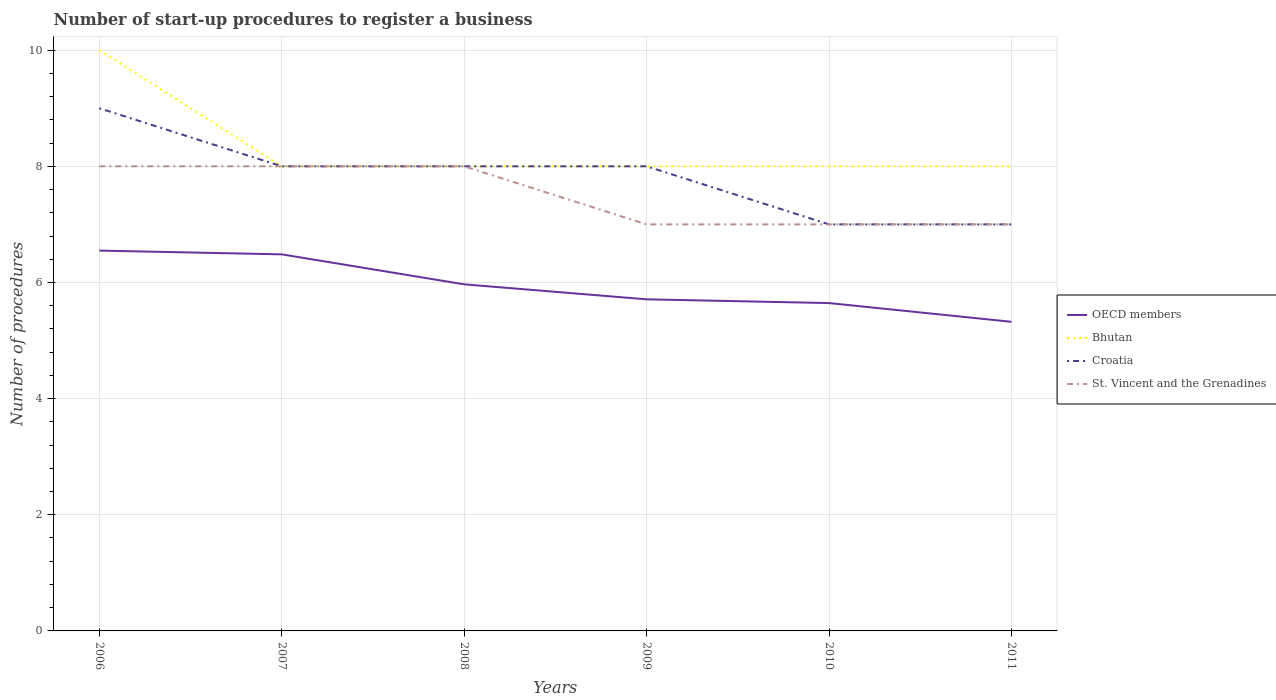Across all years, what is the maximum number of procedures required to register a business in Croatia?
Provide a succinct answer. 7. What is the difference between the highest and the second highest number of procedures required to register a business in Croatia?
Offer a very short reply. 2. How many lines are there?
Make the answer very short. 4. How many years are there in the graph?
Provide a short and direct response. 6. Are the values on the major ticks of Y-axis written in scientific E-notation?
Your answer should be compact. No. Does the graph contain any zero values?
Provide a succinct answer. No. How many legend labels are there?
Keep it short and to the point. 4. What is the title of the graph?
Provide a short and direct response. Number of start-up procedures to register a business. What is the label or title of the Y-axis?
Offer a terse response. Number of procedures. What is the Number of procedures in OECD members in 2006?
Give a very brief answer. 6.55. What is the Number of procedures of OECD members in 2007?
Your response must be concise. 6.48. What is the Number of procedures in OECD members in 2008?
Provide a short and direct response. 5.97. What is the Number of procedures of Croatia in 2008?
Your answer should be very brief. 8. What is the Number of procedures in OECD members in 2009?
Offer a very short reply. 5.71. What is the Number of procedures in St. Vincent and the Grenadines in 2009?
Keep it short and to the point. 7. What is the Number of procedures of OECD members in 2010?
Provide a succinct answer. 5.65. What is the Number of procedures in Bhutan in 2010?
Keep it short and to the point. 8. What is the Number of procedures of Croatia in 2010?
Your answer should be very brief. 7. What is the Number of procedures of OECD members in 2011?
Your answer should be very brief. 5.32. What is the Number of procedures of Croatia in 2011?
Give a very brief answer. 7. What is the Number of procedures of St. Vincent and the Grenadines in 2011?
Keep it short and to the point. 7. Across all years, what is the maximum Number of procedures of OECD members?
Your answer should be compact. 6.55. Across all years, what is the maximum Number of procedures in Bhutan?
Keep it short and to the point. 10. Across all years, what is the maximum Number of procedures of St. Vincent and the Grenadines?
Keep it short and to the point. 8. Across all years, what is the minimum Number of procedures of OECD members?
Your answer should be compact. 5.32. Across all years, what is the minimum Number of procedures in Croatia?
Provide a short and direct response. 7. What is the total Number of procedures in OECD members in the graph?
Your response must be concise. 35.68. What is the total Number of procedures of Bhutan in the graph?
Give a very brief answer. 50. What is the difference between the Number of procedures in OECD members in 2006 and that in 2007?
Make the answer very short. 0.06. What is the difference between the Number of procedures in Bhutan in 2006 and that in 2007?
Your answer should be compact. 2. What is the difference between the Number of procedures in Croatia in 2006 and that in 2007?
Your response must be concise. 1. What is the difference between the Number of procedures in St. Vincent and the Grenadines in 2006 and that in 2007?
Offer a very short reply. 0. What is the difference between the Number of procedures in OECD members in 2006 and that in 2008?
Your answer should be very brief. 0.58. What is the difference between the Number of procedures of St. Vincent and the Grenadines in 2006 and that in 2008?
Provide a short and direct response. 0. What is the difference between the Number of procedures in OECD members in 2006 and that in 2009?
Make the answer very short. 0.84. What is the difference between the Number of procedures of St. Vincent and the Grenadines in 2006 and that in 2009?
Offer a very short reply. 1. What is the difference between the Number of procedures in OECD members in 2006 and that in 2010?
Provide a short and direct response. 0.9. What is the difference between the Number of procedures in Bhutan in 2006 and that in 2010?
Make the answer very short. 2. What is the difference between the Number of procedures in Croatia in 2006 and that in 2010?
Your answer should be compact. 2. What is the difference between the Number of procedures of St. Vincent and the Grenadines in 2006 and that in 2010?
Provide a succinct answer. 1. What is the difference between the Number of procedures of OECD members in 2006 and that in 2011?
Make the answer very short. 1.23. What is the difference between the Number of procedures in Bhutan in 2006 and that in 2011?
Ensure brevity in your answer.  2. What is the difference between the Number of procedures in St. Vincent and the Grenadines in 2006 and that in 2011?
Provide a short and direct response. 1. What is the difference between the Number of procedures in OECD members in 2007 and that in 2008?
Ensure brevity in your answer.  0.52. What is the difference between the Number of procedures of Bhutan in 2007 and that in 2008?
Keep it short and to the point. 0. What is the difference between the Number of procedures of Croatia in 2007 and that in 2008?
Your answer should be very brief. 0. What is the difference between the Number of procedures in OECD members in 2007 and that in 2009?
Offer a terse response. 0.77. What is the difference between the Number of procedures of Bhutan in 2007 and that in 2009?
Provide a short and direct response. 0. What is the difference between the Number of procedures of OECD members in 2007 and that in 2010?
Make the answer very short. 0.84. What is the difference between the Number of procedures of Bhutan in 2007 and that in 2010?
Make the answer very short. 0. What is the difference between the Number of procedures in St. Vincent and the Grenadines in 2007 and that in 2010?
Ensure brevity in your answer.  1. What is the difference between the Number of procedures in OECD members in 2007 and that in 2011?
Keep it short and to the point. 1.16. What is the difference between the Number of procedures of Bhutan in 2007 and that in 2011?
Ensure brevity in your answer.  0. What is the difference between the Number of procedures of Croatia in 2007 and that in 2011?
Keep it short and to the point. 1. What is the difference between the Number of procedures in St. Vincent and the Grenadines in 2007 and that in 2011?
Your response must be concise. 1. What is the difference between the Number of procedures of OECD members in 2008 and that in 2009?
Provide a succinct answer. 0.26. What is the difference between the Number of procedures in Bhutan in 2008 and that in 2009?
Your response must be concise. 0. What is the difference between the Number of procedures of OECD members in 2008 and that in 2010?
Offer a very short reply. 0.32. What is the difference between the Number of procedures of Bhutan in 2008 and that in 2010?
Keep it short and to the point. 0. What is the difference between the Number of procedures in Croatia in 2008 and that in 2010?
Keep it short and to the point. 1. What is the difference between the Number of procedures in OECD members in 2008 and that in 2011?
Offer a terse response. 0.65. What is the difference between the Number of procedures of St. Vincent and the Grenadines in 2008 and that in 2011?
Your response must be concise. 1. What is the difference between the Number of procedures in OECD members in 2009 and that in 2010?
Make the answer very short. 0.06. What is the difference between the Number of procedures of Croatia in 2009 and that in 2010?
Your answer should be compact. 1. What is the difference between the Number of procedures in OECD members in 2009 and that in 2011?
Offer a terse response. 0.39. What is the difference between the Number of procedures in Croatia in 2009 and that in 2011?
Your answer should be very brief. 1. What is the difference between the Number of procedures of St. Vincent and the Grenadines in 2009 and that in 2011?
Provide a succinct answer. 0. What is the difference between the Number of procedures of OECD members in 2010 and that in 2011?
Keep it short and to the point. 0.32. What is the difference between the Number of procedures of Bhutan in 2010 and that in 2011?
Provide a short and direct response. 0. What is the difference between the Number of procedures in OECD members in 2006 and the Number of procedures in Bhutan in 2007?
Provide a succinct answer. -1.45. What is the difference between the Number of procedures of OECD members in 2006 and the Number of procedures of Croatia in 2007?
Provide a short and direct response. -1.45. What is the difference between the Number of procedures in OECD members in 2006 and the Number of procedures in St. Vincent and the Grenadines in 2007?
Your answer should be very brief. -1.45. What is the difference between the Number of procedures in Bhutan in 2006 and the Number of procedures in Croatia in 2007?
Keep it short and to the point. 2. What is the difference between the Number of procedures in Bhutan in 2006 and the Number of procedures in St. Vincent and the Grenadines in 2007?
Make the answer very short. 2. What is the difference between the Number of procedures of Croatia in 2006 and the Number of procedures of St. Vincent and the Grenadines in 2007?
Offer a very short reply. 1. What is the difference between the Number of procedures of OECD members in 2006 and the Number of procedures of Bhutan in 2008?
Provide a short and direct response. -1.45. What is the difference between the Number of procedures in OECD members in 2006 and the Number of procedures in Croatia in 2008?
Your response must be concise. -1.45. What is the difference between the Number of procedures of OECD members in 2006 and the Number of procedures of St. Vincent and the Grenadines in 2008?
Make the answer very short. -1.45. What is the difference between the Number of procedures in Bhutan in 2006 and the Number of procedures in St. Vincent and the Grenadines in 2008?
Your answer should be very brief. 2. What is the difference between the Number of procedures of OECD members in 2006 and the Number of procedures of Bhutan in 2009?
Provide a short and direct response. -1.45. What is the difference between the Number of procedures in OECD members in 2006 and the Number of procedures in Croatia in 2009?
Offer a terse response. -1.45. What is the difference between the Number of procedures of OECD members in 2006 and the Number of procedures of St. Vincent and the Grenadines in 2009?
Provide a succinct answer. -0.45. What is the difference between the Number of procedures in Bhutan in 2006 and the Number of procedures in Croatia in 2009?
Offer a terse response. 2. What is the difference between the Number of procedures in OECD members in 2006 and the Number of procedures in Bhutan in 2010?
Provide a succinct answer. -1.45. What is the difference between the Number of procedures in OECD members in 2006 and the Number of procedures in Croatia in 2010?
Offer a terse response. -0.45. What is the difference between the Number of procedures of OECD members in 2006 and the Number of procedures of St. Vincent and the Grenadines in 2010?
Your answer should be very brief. -0.45. What is the difference between the Number of procedures in Bhutan in 2006 and the Number of procedures in Croatia in 2010?
Provide a short and direct response. 3. What is the difference between the Number of procedures of Bhutan in 2006 and the Number of procedures of St. Vincent and the Grenadines in 2010?
Your response must be concise. 3. What is the difference between the Number of procedures in OECD members in 2006 and the Number of procedures in Bhutan in 2011?
Provide a succinct answer. -1.45. What is the difference between the Number of procedures of OECD members in 2006 and the Number of procedures of Croatia in 2011?
Your answer should be very brief. -0.45. What is the difference between the Number of procedures in OECD members in 2006 and the Number of procedures in St. Vincent and the Grenadines in 2011?
Provide a succinct answer. -0.45. What is the difference between the Number of procedures in Croatia in 2006 and the Number of procedures in St. Vincent and the Grenadines in 2011?
Your answer should be compact. 2. What is the difference between the Number of procedures in OECD members in 2007 and the Number of procedures in Bhutan in 2008?
Offer a very short reply. -1.52. What is the difference between the Number of procedures of OECD members in 2007 and the Number of procedures of Croatia in 2008?
Offer a terse response. -1.52. What is the difference between the Number of procedures in OECD members in 2007 and the Number of procedures in St. Vincent and the Grenadines in 2008?
Ensure brevity in your answer.  -1.52. What is the difference between the Number of procedures in Bhutan in 2007 and the Number of procedures in Croatia in 2008?
Keep it short and to the point. 0. What is the difference between the Number of procedures of OECD members in 2007 and the Number of procedures of Bhutan in 2009?
Offer a terse response. -1.52. What is the difference between the Number of procedures in OECD members in 2007 and the Number of procedures in Croatia in 2009?
Provide a succinct answer. -1.52. What is the difference between the Number of procedures of OECD members in 2007 and the Number of procedures of St. Vincent and the Grenadines in 2009?
Your response must be concise. -0.52. What is the difference between the Number of procedures of Bhutan in 2007 and the Number of procedures of Croatia in 2009?
Ensure brevity in your answer.  0. What is the difference between the Number of procedures in Bhutan in 2007 and the Number of procedures in St. Vincent and the Grenadines in 2009?
Your response must be concise. 1. What is the difference between the Number of procedures in OECD members in 2007 and the Number of procedures in Bhutan in 2010?
Provide a short and direct response. -1.52. What is the difference between the Number of procedures in OECD members in 2007 and the Number of procedures in Croatia in 2010?
Your response must be concise. -0.52. What is the difference between the Number of procedures in OECD members in 2007 and the Number of procedures in St. Vincent and the Grenadines in 2010?
Your answer should be very brief. -0.52. What is the difference between the Number of procedures in Bhutan in 2007 and the Number of procedures in Croatia in 2010?
Provide a short and direct response. 1. What is the difference between the Number of procedures in Bhutan in 2007 and the Number of procedures in St. Vincent and the Grenadines in 2010?
Your response must be concise. 1. What is the difference between the Number of procedures in Croatia in 2007 and the Number of procedures in St. Vincent and the Grenadines in 2010?
Provide a succinct answer. 1. What is the difference between the Number of procedures of OECD members in 2007 and the Number of procedures of Bhutan in 2011?
Provide a short and direct response. -1.52. What is the difference between the Number of procedures in OECD members in 2007 and the Number of procedures in Croatia in 2011?
Keep it short and to the point. -0.52. What is the difference between the Number of procedures of OECD members in 2007 and the Number of procedures of St. Vincent and the Grenadines in 2011?
Keep it short and to the point. -0.52. What is the difference between the Number of procedures of Bhutan in 2007 and the Number of procedures of Croatia in 2011?
Your answer should be very brief. 1. What is the difference between the Number of procedures in Bhutan in 2007 and the Number of procedures in St. Vincent and the Grenadines in 2011?
Give a very brief answer. 1. What is the difference between the Number of procedures of OECD members in 2008 and the Number of procedures of Bhutan in 2009?
Your response must be concise. -2.03. What is the difference between the Number of procedures in OECD members in 2008 and the Number of procedures in Croatia in 2009?
Provide a short and direct response. -2.03. What is the difference between the Number of procedures of OECD members in 2008 and the Number of procedures of St. Vincent and the Grenadines in 2009?
Ensure brevity in your answer.  -1.03. What is the difference between the Number of procedures of Bhutan in 2008 and the Number of procedures of Croatia in 2009?
Your response must be concise. 0. What is the difference between the Number of procedures of Bhutan in 2008 and the Number of procedures of St. Vincent and the Grenadines in 2009?
Ensure brevity in your answer.  1. What is the difference between the Number of procedures in Croatia in 2008 and the Number of procedures in St. Vincent and the Grenadines in 2009?
Ensure brevity in your answer.  1. What is the difference between the Number of procedures of OECD members in 2008 and the Number of procedures of Bhutan in 2010?
Offer a terse response. -2.03. What is the difference between the Number of procedures in OECD members in 2008 and the Number of procedures in Croatia in 2010?
Your answer should be very brief. -1.03. What is the difference between the Number of procedures of OECD members in 2008 and the Number of procedures of St. Vincent and the Grenadines in 2010?
Offer a very short reply. -1.03. What is the difference between the Number of procedures of Bhutan in 2008 and the Number of procedures of Croatia in 2010?
Ensure brevity in your answer.  1. What is the difference between the Number of procedures of OECD members in 2008 and the Number of procedures of Bhutan in 2011?
Offer a terse response. -2.03. What is the difference between the Number of procedures of OECD members in 2008 and the Number of procedures of Croatia in 2011?
Ensure brevity in your answer.  -1.03. What is the difference between the Number of procedures of OECD members in 2008 and the Number of procedures of St. Vincent and the Grenadines in 2011?
Provide a succinct answer. -1.03. What is the difference between the Number of procedures in Bhutan in 2008 and the Number of procedures in St. Vincent and the Grenadines in 2011?
Your answer should be very brief. 1. What is the difference between the Number of procedures of OECD members in 2009 and the Number of procedures of Bhutan in 2010?
Provide a succinct answer. -2.29. What is the difference between the Number of procedures in OECD members in 2009 and the Number of procedures in Croatia in 2010?
Make the answer very short. -1.29. What is the difference between the Number of procedures in OECD members in 2009 and the Number of procedures in St. Vincent and the Grenadines in 2010?
Your answer should be compact. -1.29. What is the difference between the Number of procedures of Bhutan in 2009 and the Number of procedures of Croatia in 2010?
Your answer should be very brief. 1. What is the difference between the Number of procedures in Bhutan in 2009 and the Number of procedures in St. Vincent and the Grenadines in 2010?
Offer a very short reply. 1. What is the difference between the Number of procedures of OECD members in 2009 and the Number of procedures of Bhutan in 2011?
Keep it short and to the point. -2.29. What is the difference between the Number of procedures in OECD members in 2009 and the Number of procedures in Croatia in 2011?
Make the answer very short. -1.29. What is the difference between the Number of procedures of OECD members in 2009 and the Number of procedures of St. Vincent and the Grenadines in 2011?
Give a very brief answer. -1.29. What is the difference between the Number of procedures of Bhutan in 2009 and the Number of procedures of Croatia in 2011?
Ensure brevity in your answer.  1. What is the difference between the Number of procedures in Bhutan in 2009 and the Number of procedures in St. Vincent and the Grenadines in 2011?
Your response must be concise. 1. What is the difference between the Number of procedures in OECD members in 2010 and the Number of procedures in Bhutan in 2011?
Provide a succinct answer. -2.35. What is the difference between the Number of procedures in OECD members in 2010 and the Number of procedures in Croatia in 2011?
Make the answer very short. -1.35. What is the difference between the Number of procedures of OECD members in 2010 and the Number of procedures of St. Vincent and the Grenadines in 2011?
Offer a terse response. -1.35. What is the difference between the Number of procedures of Bhutan in 2010 and the Number of procedures of St. Vincent and the Grenadines in 2011?
Keep it short and to the point. 1. What is the difference between the Number of procedures in Croatia in 2010 and the Number of procedures in St. Vincent and the Grenadines in 2011?
Provide a short and direct response. 0. What is the average Number of procedures of OECD members per year?
Provide a short and direct response. 5.95. What is the average Number of procedures in Bhutan per year?
Your response must be concise. 8.33. What is the average Number of procedures of Croatia per year?
Keep it short and to the point. 7.83. In the year 2006, what is the difference between the Number of procedures in OECD members and Number of procedures in Bhutan?
Your answer should be compact. -3.45. In the year 2006, what is the difference between the Number of procedures in OECD members and Number of procedures in Croatia?
Your answer should be very brief. -2.45. In the year 2006, what is the difference between the Number of procedures of OECD members and Number of procedures of St. Vincent and the Grenadines?
Provide a succinct answer. -1.45. In the year 2006, what is the difference between the Number of procedures in Bhutan and Number of procedures in St. Vincent and the Grenadines?
Ensure brevity in your answer.  2. In the year 2007, what is the difference between the Number of procedures of OECD members and Number of procedures of Bhutan?
Your answer should be compact. -1.52. In the year 2007, what is the difference between the Number of procedures in OECD members and Number of procedures in Croatia?
Provide a succinct answer. -1.52. In the year 2007, what is the difference between the Number of procedures of OECD members and Number of procedures of St. Vincent and the Grenadines?
Keep it short and to the point. -1.52. In the year 2007, what is the difference between the Number of procedures in Bhutan and Number of procedures in Croatia?
Provide a succinct answer. 0. In the year 2007, what is the difference between the Number of procedures of Bhutan and Number of procedures of St. Vincent and the Grenadines?
Provide a succinct answer. 0. In the year 2007, what is the difference between the Number of procedures in Croatia and Number of procedures in St. Vincent and the Grenadines?
Offer a terse response. 0. In the year 2008, what is the difference between the Number of procedures of OECD members and Number of procedures of Bhutan?
Your response must be concise. -2.03. In the year 2008, what is the difference between the Number of procedures in OECD members and Number of procedures in Croatia?
Make the answer very short. -2.03. In the year 2008, what is the difference between the Number of procedures of OECD members and Number of procedures of St. Vincent and the Grenadines?
Your response must be concise. -2.03. In the year 2008, what is the difference between the Number of procedures of Bhutan and Number of procedures of Croatia?
Keep it short and to the point. 0. In the year 2009, what is the difference between the Number of procedures in OECD members and Number of procedures in Bhutan?
Offer a terse response. -2.29. In the year 2009, what is the difference between the Number of procedures of OECD members and Number of procedures of Croatia?
Provide a short and direct response. -2.29. In the year 2009, what is the difference between the Number of procedures in OECD members and Number of procedures in St. Vincent and the Grenadines?
Offer a terse response. -1.29. In the year 2009, what is the difference between the Number of procedures in Bhutan and Number of procedures in Croatia?
Provide a short and direct response. 0. In the year 2009, what is the difference between the Number of procedures of Bhutan and Number of procedures of St. Vincent and the Grenadines?
Provide a short and direct response. 1. In the year 2009, what is the difference between the Number of procedures of Croatia and Number of procedures of St. Vincent and the Grenadines?
Offer a terse response. 1. In the year 2010, what is the difference between the Number of procedures in OECD members and Number of procedures in Bhutan?
Provide a succinct answer. -2.35. In the year 2010, what is the difference between the Number of procedures in OECD members and Number of procedures in Croatia?
Ensure brevity in your answer.  -1.35. In the year 2010, what is the difference between the Number of procedures of OECD members and Number of procedures of St. Vincent and the Grenadines?
Give a very brief answer. -1.35. In the year 2010, what is the difference between the Number of procedures of Croatia and Number of procedures of St. Vincent and the Grenadines?
Offer a very short reply. 0. In the year 2011, what is the difference between the Number of procedures in OECD members and Number of procedures in Bhutan?
Ensure brevity in your answer.  -2.68. In the year 2011, what is the difference between the Number of procedures in OECD members and Number of procedures in Croatia?
Give a very brief answer. -1.68. In the year 2011, what is the difference between the Number of procedures in OECD members and Number of procedures in St. Vincent and the Grenadines?
Give a very brief answer. -1.68. What is the ratio of the Number of procedures in Bhutan in 2006 to that in 2007?
Your answer should be compact. 1.25. What is the ratio of the Number of procedures in St. Vincent and the Grenadines in 2006 to that in 2007?
Keep it short and to the point. 1. What is the ratio of the Number of procedures of OECD members in 2006 to that in 2008?
Keep it short and to the point. 1.1. What is the ratio of the Number of procedures of Bhutan in 2006 to that in 2008?
Give a very brief answer. 1.25. What is the ratio of the Number of procedures in Croatia in 2006 to that in 2008?
Provide a succinct answer. 1.12. What is the ratio of the Number of procedures in OECD members in 2006 to that in 2009?
Offer a terse response. 1.15. What is the ratio of the Number of procedures of Bhutan in 2006 to that in 2009?
Make the answer very short. 1.25. What is the ratio of the Number of procedures in OECD members in 2006 to that in 2010?
Give a very brief answer. 1.16. What is the ratio of the Number of procedures of Bhutan in 2006 to that in 2010?
Make the answer very short. 1.25. What is the ratio of the Number of procedures of Croatia in 2006 to that in 2010?
Provide a short and direct response. 1.29. What is the ratio of the Number of procedures of OECD members in 2006 to that in 2011?
Ensure brevity in your answer.  1.23. What is the ratio of the Number of procedures of Bhutan in 2006 to that in 2011?
Your answer should be very brief. 1.25. What is the ratio of the Number of procedures of St. Vincent and the Grenadines in 2006 to that in 2011?
Provide a short and direct response. 1.14. What is the ratio of the Number of procedures of OECD members in 2007 to that in 2008?
Keep it short and to the point. 1.09. What is the ratio of the Number of procedures in Bhutan in 2007 to that in 2008?
Your answer should be compact. 1. What is the ratio of the Number of procedures in OECD members in 2007 to that in 2009?
Offer a very short reply. 1.14. What is the ratio of the Number of procedures in Bhutan in 2007 to that in 2009?
Offer a very short reply. 1. What is the ratio of the Number of procedures in Croatia in 2007 to that in 2009?
Offer a very short reply. 1. What is the ratio of the Number of procedures in St. Vincent and the Grenadines in 2007 to that in 2009?
Offer a very short reply. 1.14. What is the ratio of the Number of procedures in OECD members in 2007 to that in 2010?
Offer a terse response. 1.15. What is the ratio of the Number of procedures of Croatia in 2007 to that in 2010?
Offer a very short reply. 1.14. What is the ratio of the Number of procedures in St. Vincent and the Grenadines in 2007 to that in 2010?
Your answer should be very brief. 1.14. What is the ratio of the Number of procedures of OECD members in 2007 to that in 2011?
Your response must be concise. 1.22. What is the ratio of the Number of procedures of Bhutan in 2007 to that in 2011?
Offer a terse response. 1. What is the ratio of the Number of procedures in Croatia in 2007 to that in 2011?
Provide a succinct answer. 1.14. What is the ratio of the Number of procedures of St. Vincent and the Grenadines in 2007 to that in 2011?
Ensure brevity in your answer.  1.14. What is the ratio of the Number of procedures of OECD members in 2008 to that in 2009?
Your answer should be compact. 1.05. What is the ratio of the Number of procedures of OECD members in 2008 to that in 2010?
Give a very brief answer. 1.06. What is the ratio of the Number of procedures in OECD members in 2008 to that in 2011?
Provide a short and direct response. 1.12. What is the ratio of the Number of procedures in Bhutan in 2008 to that in 2011?
Ensure brevity in your answer.  1. What is the ratio of the Number of procedures of Croatia in 2008 to that in 2011?
Provide a short and direct response. 1.14. What is the ratio of the Number of procedures of St. Vincent and the Grenadines in 2008 to that in 2011?
Make the answer very short. 1.14. What is the ratio of the Number of procedures in OECD members in 2009 to that in 2010?
Your response must be concise. 1.01. What is the ratio of the Number of procedures in Croatia in 2009 to that in 2010?
Ensure brevity in your answer.  1.14. What is the ratio of the Number of procedures of St. Vincent and the Grenadines in 2009 to that in 2010?
Give a very brief answer. 1. What is the ratio of the Number of procedures in OECD members in 2009 to that in 2011?
Offer a terse response. 1.07. What is the ratio of the Number of procedures of OECD members in 2010 to that in 2011?
Your answer should be compact. 1.06. What is the ratio of the Number of procedures of Bhutan in 2010 to that in 2011?
Your answer should be compact. 1. What is the ratio of the Number of procedures in Croatia in 2010 to that in 2011?
Make the answer very short. 1. What is the difference between the highest and the second highest Number of procedures in OECD members?
Offer a very short reply. 0.06. What is the difference between the highest and the second highest Number of procedures of Croatia?
Your answer should be very brief. 1. What is the difference between the highest and the lowest Number of procedures in OECD members?
Your response must be concise. 1.23. What is the difference between the highest and the lowest Number of procedures of Bhutan?
Provide a short and direct response. 2. 